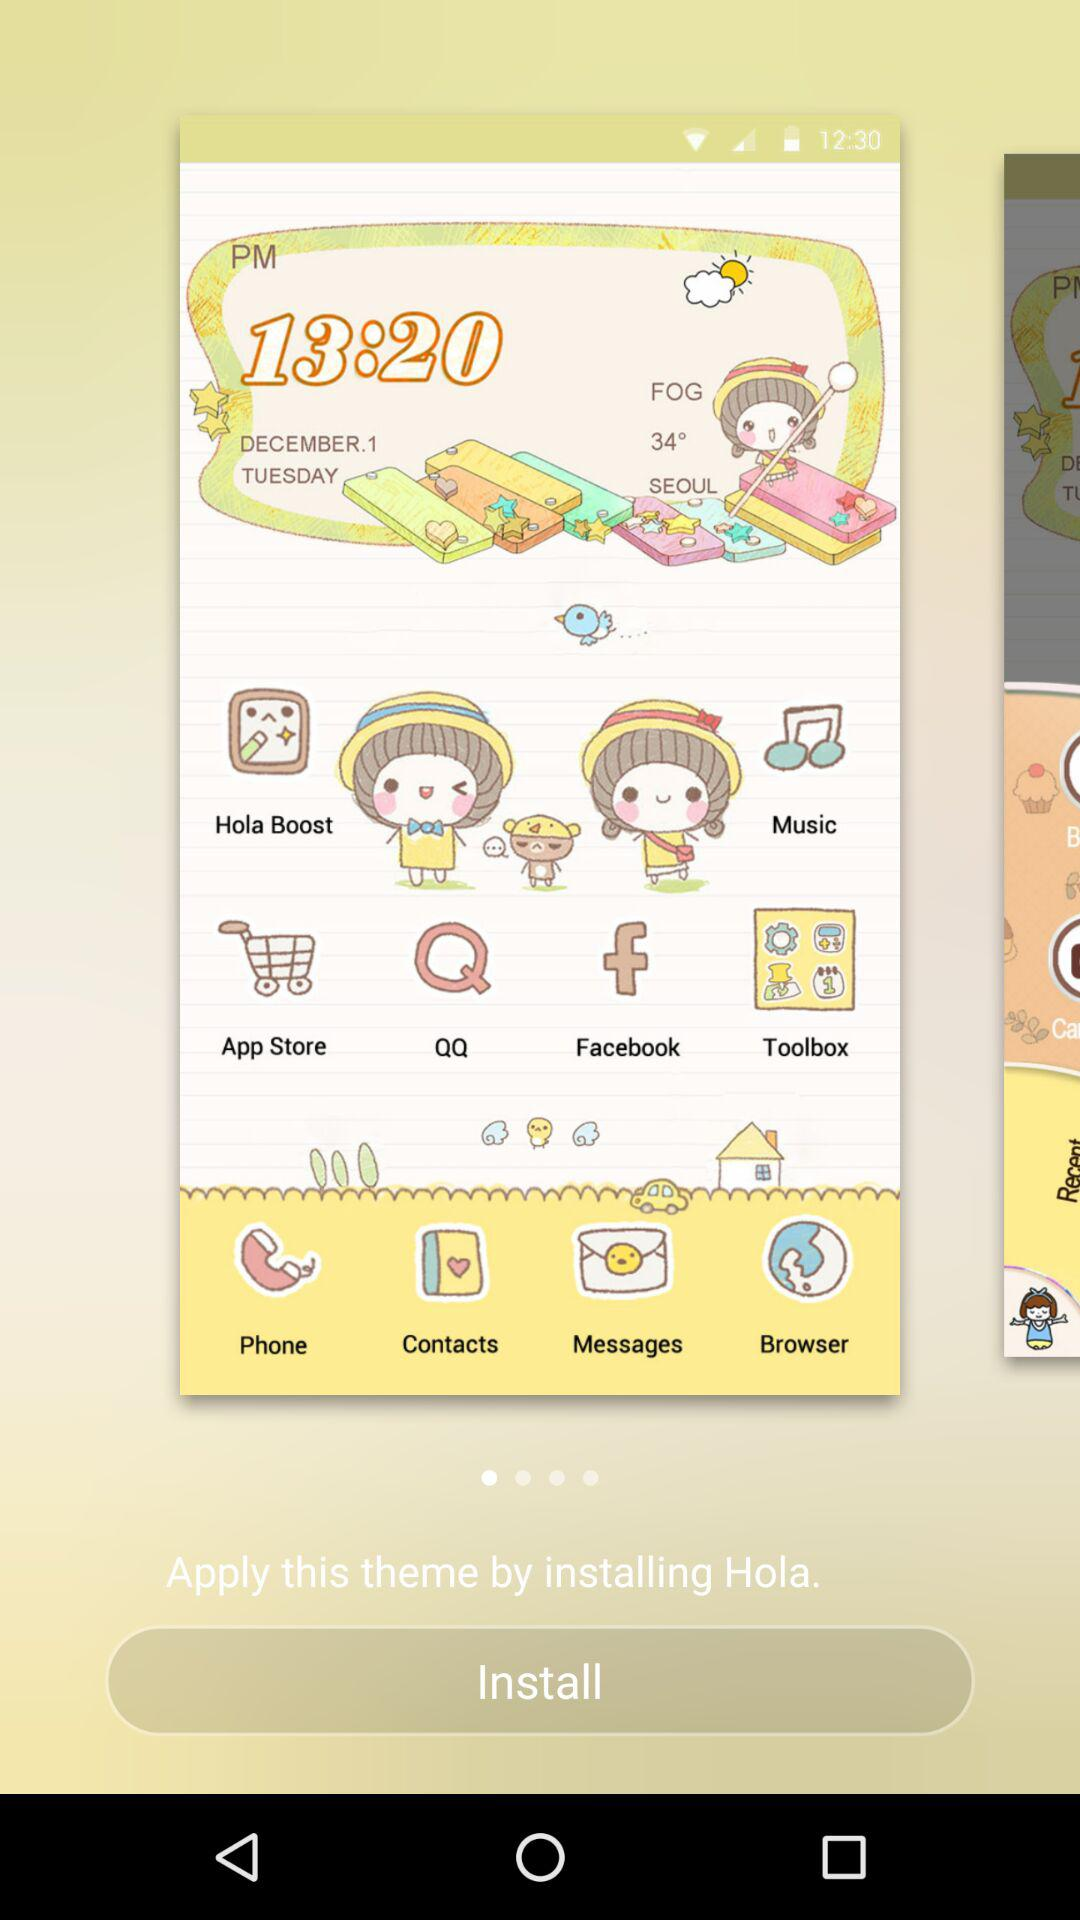What is the temperature? The temperature is 34°. 